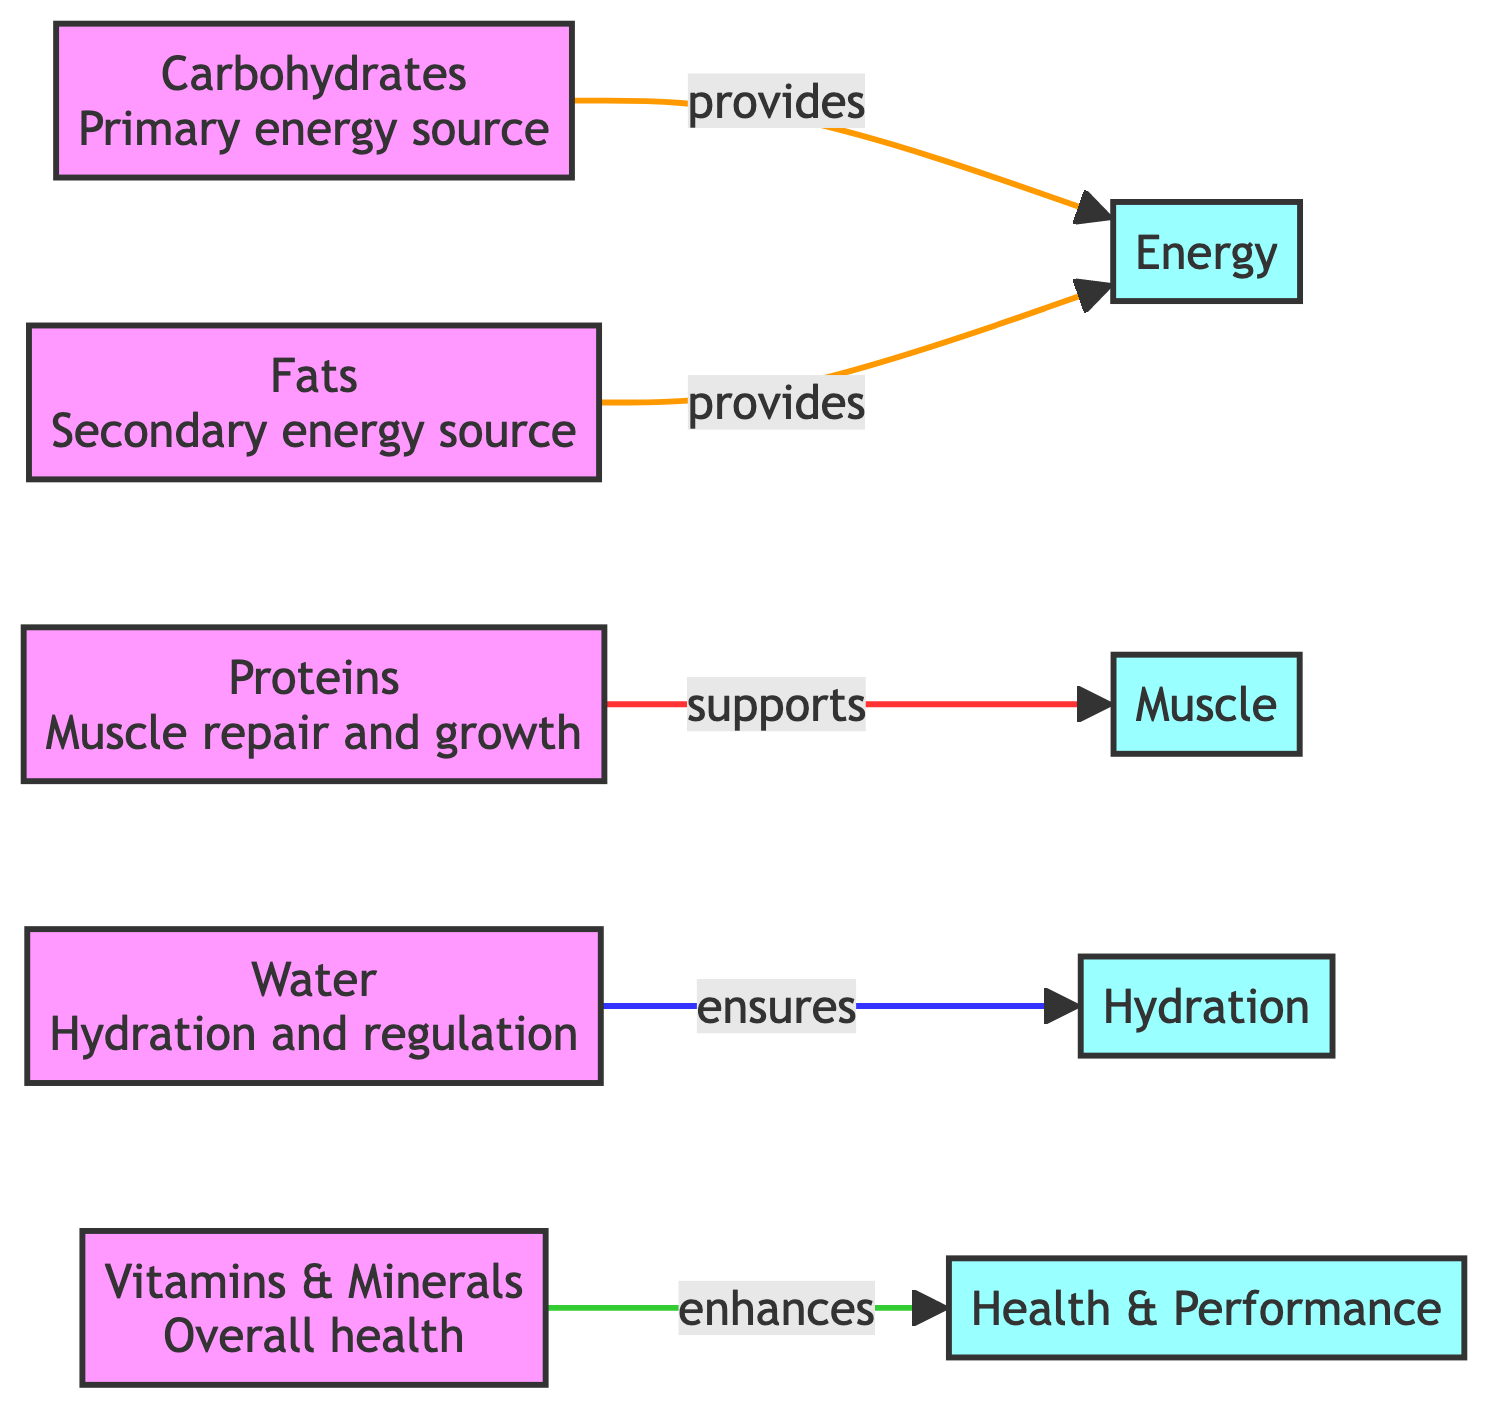What are the primary content areas in the diagram? The diagram contains five primary nutrients: carbohydrates, proteins, fats, water, and vitamins & minerals.
Answer: carbohydrates, proteins, fats, water, vitamins & minerals How many nutrients are represented in the diagram? Upon counting, there are five unique nutrient types depicted in the diagram.
Answer: 5 Which nutrient is indicated as the primary energy source? The diagram highlights carbohydrates as the primary energy source for athletes.
Answer: Carbohydrates What role do proteins play according to the diagram? The diagram specifies that proteins support muscle repair and growth in athletes.
Answer: Muscle repair and growth Which nutrient is linked to ensuring hydration? The diagram illustrates that water is the nutrient ensuring hydration.
Answer: Water What is the secondary energy source mentioned? The diagram describes fats as the secondary energy source for athletes.
Answer: Fats Which nutrient enhances health and performance? Vitamins & minerals are indicated in the diagram as enhancing overall health and performance.
Answer: Vitamins & Minerals How do carbohydrates and fats differ in their function? Carbohydrates are described as the primary energy source, while fats serve as a secondary energy source, indicating their different roles in energy provision.
Answer: Primary vs Secondary Energy Source Explain how water contributes to athletic performance in the diagram. The diagram specifies water's role in ensuring hydration, which is critical for athletic performance and function. It supports overall well-being during physical activity.
Answer: Hydration What functions do vitamins and minerals support according to the diagram? The diagram states that vitamins and minerals enhance health and performance, indicating their supportive role in maintaining overall well-being for athletes.
Answer: Health & Performance 